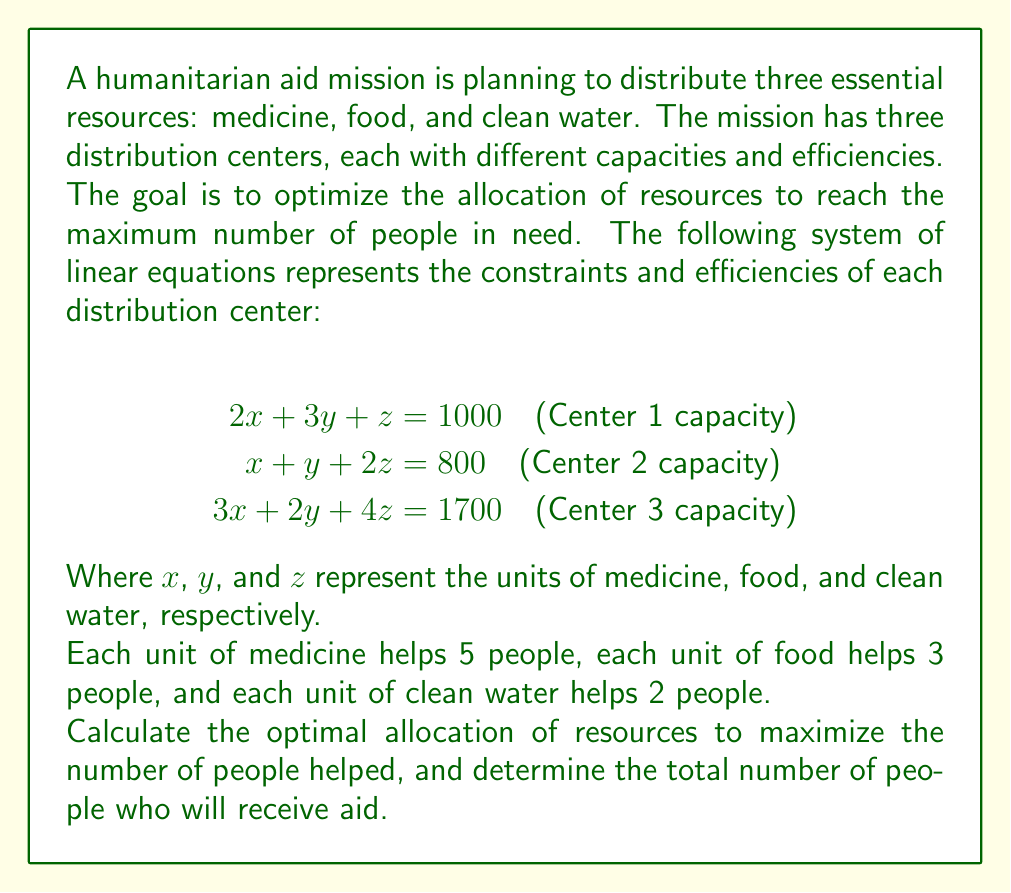Give your solution to this math problem. To solve this problem, we'll follow these steps:

1. Solve the system of linear equations to find the values of $x$, $y$, and $z$.
2. Calculate the number of people helped by each resource.
3. Sum up the total number of people helped.

Step 1: Solving the system of linear equations

We can use Gaussian elimination or matrix methods to solve this system. Let's use the elimination method:

Multiply equation (1) by 3 and equation (2) by -2:
$$\begin{align}
6x + 9y + 3z &= 3000 \quad (1')\\
-2x - 2y - 4z &= -1600 \quad (2')
\end{align}$$

Add (1') and (2'):
$$4x + 7y - z = 1400 \quad (3)$$

Now, multiply equation (1) by -1 and add it to equation (3):
$$2x + 4y - 2z = 400 \quad (4)$$

From equation (2), we have:
$$x + y + 2z = 800 \quad (2)$$

Subtracting (2) from (4):
$$x + 3y - 4z = -400 \quad (5)$$

Now we have:
$$\begin{align}
x + y + 2z &= 800 \quad (2)\\
x + 3y - 4z &= -400 \quad (5)
\end{align}$$

Subtracting (2) from (5):
$$2y - 6z = -1200$$
$$y - 3z = -600 \quad (6)$$

From (6): $y = 3z - 600$

Substituting this into (2):
$$x + (3z - 600) + 2z = 800$$
$$x + 5z = 1400$$
$$x = 1400 - 5z \quad (7)$$

Substituting (6) and (7) into (1):
$$2(1400 - 5z) + 3(3z - 600) + z = 1000$$
$$2800 - 10z + 9z - 1800 + z = 1000$$
$$1000 = 1000$$

This equation is always true, which means our system has infinite solutions. We need to choose values that maximize the number of people helped.

Step 2: Calculating the number of people helped

Let's express the number of people helped in terms of $z$:

Medicine ($x$): $5(1400 - 5z)$ people
Food ($y$): $3(3z - 600)$ people
Water ($z$): $2z$ people

Total: $5(1400 - 5z) + 3(3z - 600) + 2z$

Step 3: Maximizing the number of people helped

Simplify the expression:
$$7000 - 25z + 9z - 1800 + 2z = 5200 - 14z$$

To maximize this, we need to minimize $z$ (since the coefficient is negative).

The constraints are:
$z \geq 0$ (we can't have negative resources)
$3z - 600 \geq 0$ (from $y = 3z - 600$, $y$ must be non-negative)
$1400 - 5z \geq 0$ (from $x = 1400 - 5z$, $x$ must be non-negative)

The binding constraint is $3z - 600 \geq 0$, which gives us $z \geq 200$.

Therefore, the optimal solution is:
$z = 200$
$y = 3(200) - 600 = 0$
$x = 1400 - 5(200) = 400$

The maximum number of people helped is:
$5(400) + 3(0) + 2(200) = 2400$
Answer: The optimal allocation of resources is 400 units of medicine, 0 units of food, and 200 units of clean water. This allocation will help a total of 2,400 people. 